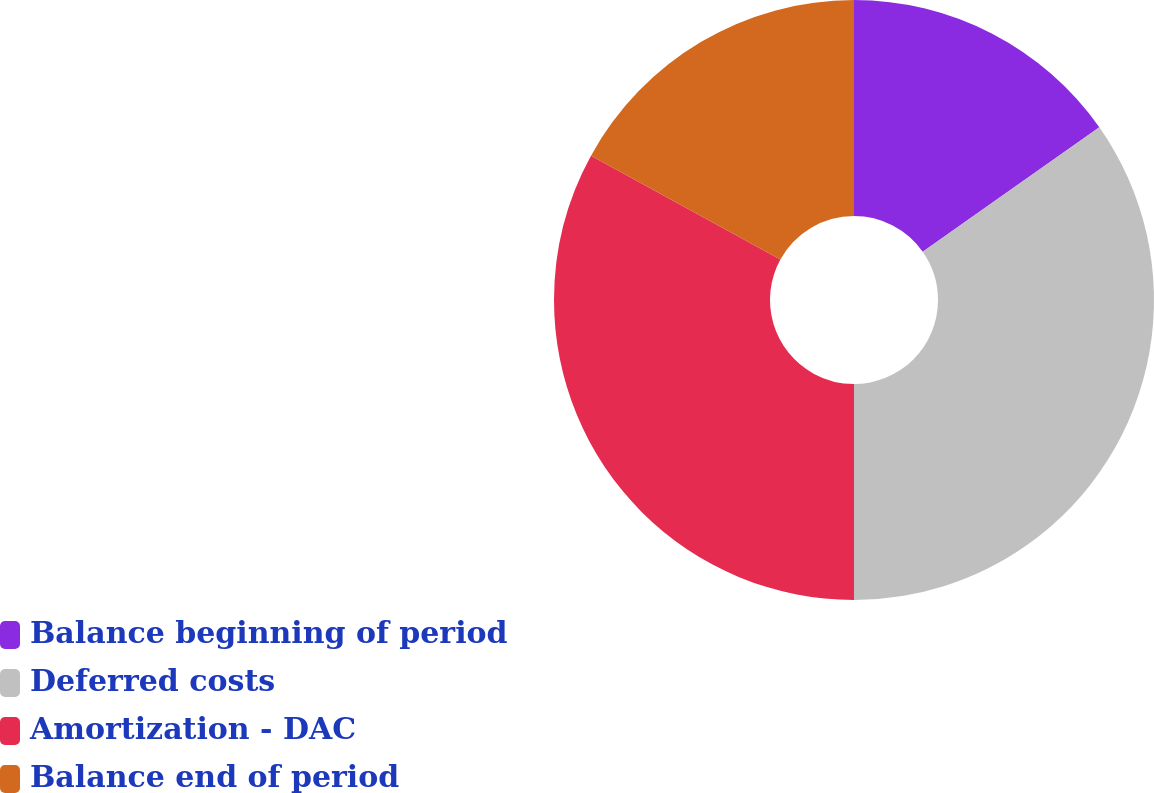Convert chart. <chart><loc_0><loc_0><loc_500><loc_500><pie_chart><fcel>Balance beginning of period<fcel>Deferred costs<fcel>Amortization - DAC<fcel>Balance end of period<nl><fcel>15.24%<fcel>34.76%<fcel>32.99%<fcel>17.01%<nl></chart> 